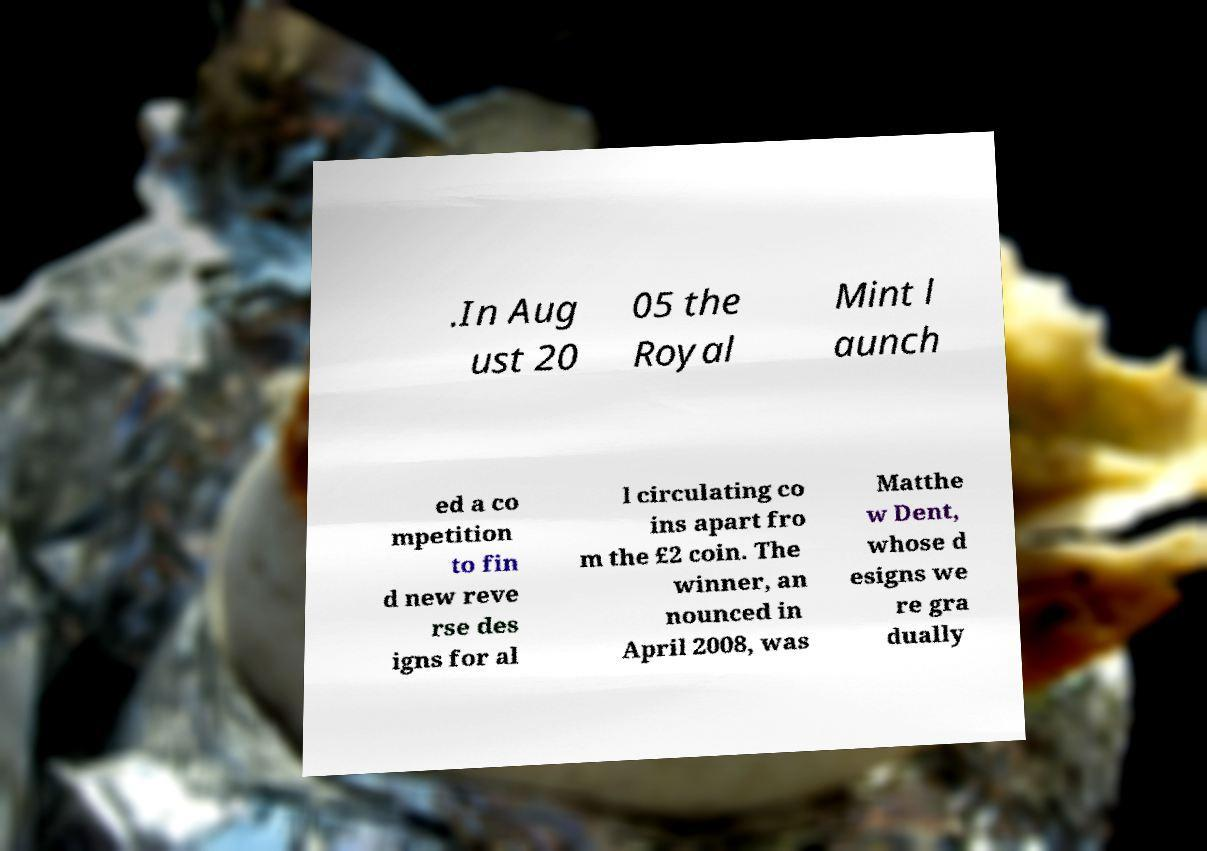Could you assist in decoding the text presented in this image and type it out clearly? .In Aug ust 20 05 the Royal Mint l aunch ed a co mpetition to fin d new reve rse des igns for al l circulating co ins apart fro m the £2 coin. The winner, an nounced in April 2008, was Matthe w Dent, whose d esigns we re gra dually 